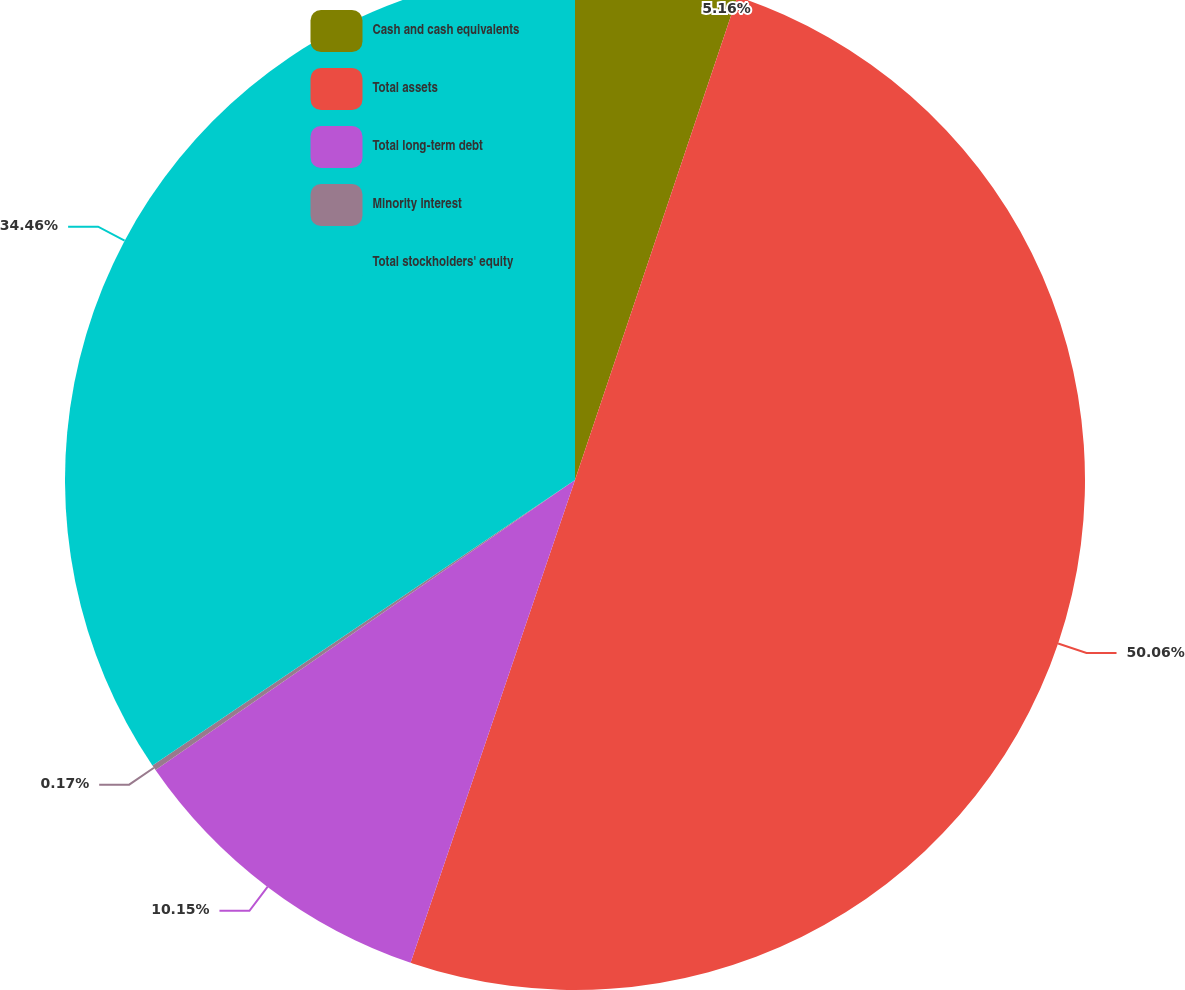Convert chart to OTSL. <chart><loc_0><loc_0><loc_500><loc_500><pie_chart><fcel>Cash and cash equivalents<fcel>Total assets<fcel>Total long-term debt<fcel>Minority interest<fcel>Total stockholders' equity<nl><fcel>5.16%<fcel>50.07%<fcel>10.15%<fcel>0.17%<fcel>34.46%<nl></chart> 